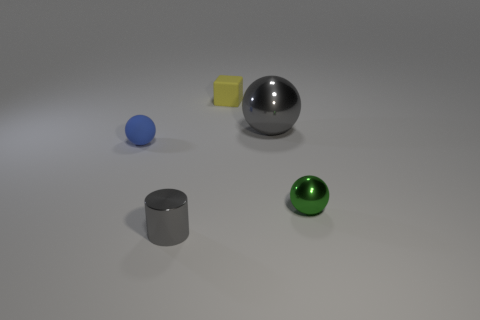The small metal thing that is the same color as the large object is what shape?
Give a very brief answer. Cylinder. How many metallic things are either tiny blue spheres or small purple cylinders?
Make the answer very short. 0. What shape is the metal object behind the small green object that is in front of the blue object?
Your response must be concise. Sphere. Is the number of yellow matte blocks behind the small rubber cube less than the number of tiny things?
Provide a short and direct response. Yes. What is the shape of the small green shiny thing?
Keep it short and to the point. Sphere. What is the size of the rubber thing that is behind the large gray metal sphere?
Your answer should be very brief. Small. What is the color of the ball that is the same size as the blue thing?
Your response must be concise. Green. Are there any tiny cylinders of the same color as the rubber block?
Your answer should be compact. No. Is the number of small blocks in front of the yellow matte object less than the number of cubes that are on the left side of the gray shiny cylinder?
Give a very brief answer. No. There is a sphere that is on the left side of the green shiny object and in front of the large object; what material is it made of?
Your answer should be very brief. Rubber. 